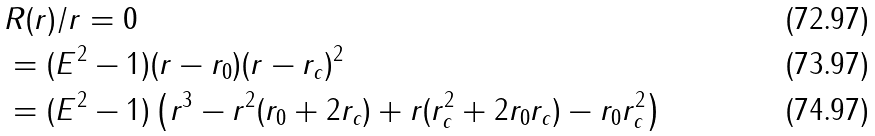<formula> <loc_0><loc_0><loc_500><loc_500>& R ( r ) / r = 0 \\ & = ( E ^ { 2 } - 1 ) ( r - r _ { 0 } ) ( r - r _ { c } ) ^ { 2 } \\ & = ( E ^ { 2 } - 1 ) \left ( r ^ { 3 } - r ^ { 2 } ( r _ { 0 } + 2 r _ { c } ) + r ( r _ { c } ^ { 2 } + 2 r _ { 0 } r _ { c } ) - r _ { 0 } r _ { c } ^ { 2 } \right )</formula> 